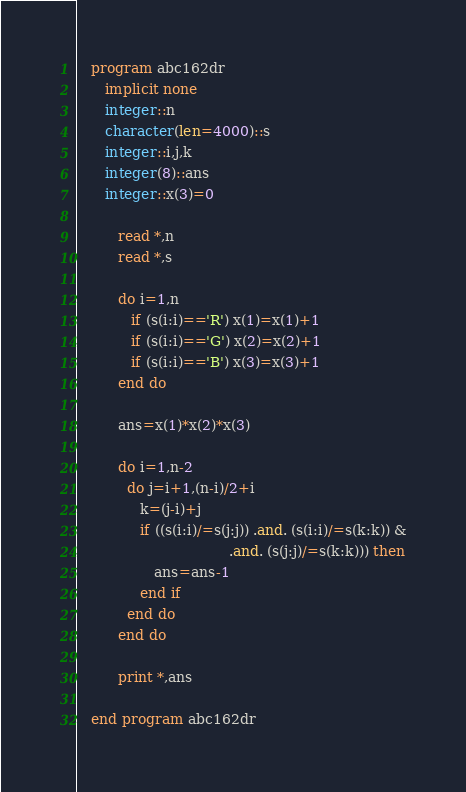Convert code to text. <code><loc_0><loc_0><loc_500><loc_500><_FORTRAN_>   program abc162dr
      implicit none
      integer::n
      character(len=4000)::s
      integer::i,j,k
      integer(8)::ans
      integer::x(3)=0

         read *,n
         read *,s

         do i=1,n
            if (s(i:i)=='R') x(1)=x(1)+1
            if (s(i:i)=='G') x(2)=x(2)+1
            if (s(i:i)=='B') x(3)=x(3)+1
         end do

         ans=x(1)*x(2)*x(3)

         do i=1,n-2
           do j=i+1,(n-i)/2+i
              k=(j-i)+j
              if ((s(i:i)/=s(j:j)) .and. (s(i:i)/=s(k:k)) &
                                  .and. (s(j:j)/=s(k:k))) then
                 ans=ans-1
              end if
           end do
         end do

         print *,ans

   end program abc162dr</code> 